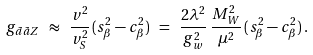Convert formula to latex. <formula><loc_0><loc_0><loc_500><loc_500>g _ { \tilde { a } \tilde { a } Z } \ \approx \ \frac { v ^ { 2 } } { v _ { S } ^ { 2 } } \, ( s _ { \beta } ^ { 2 } - c _ { \beta } ^ { 2 } ) \ = \ \frac { 2 \lambda ^ { 2 } } { g _ { w } ^ { 2 } } \, \frac { M _ { W } ^ { 2 } } { \mu ^ { 2 } } \, ( s _ { \beta } ^ { 2 } - c _ { \beta } ^ { 2 } ) \, .</formula> 